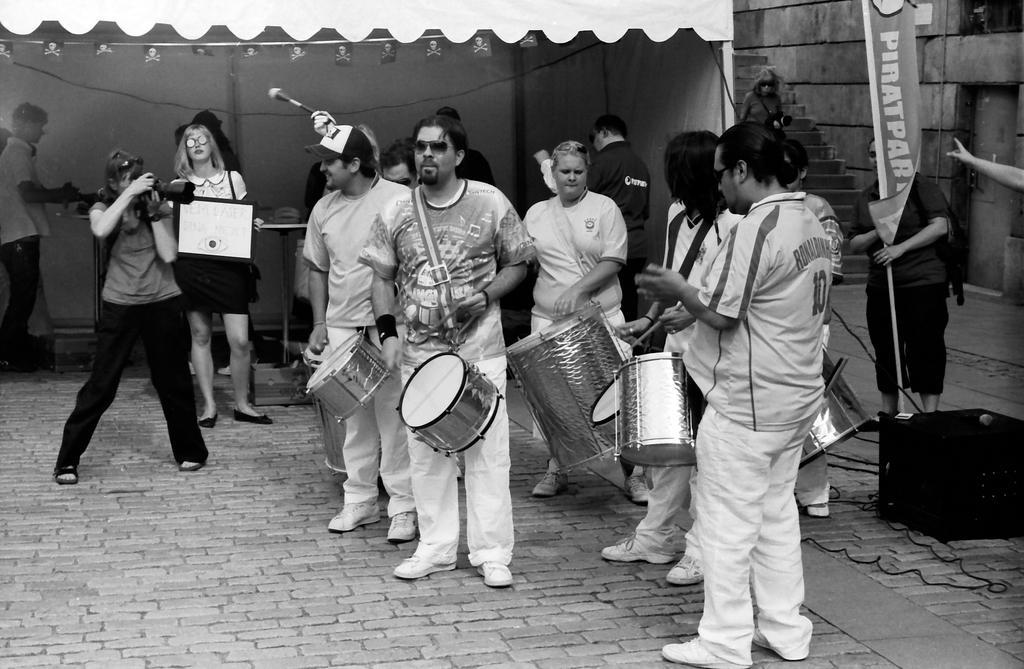How would you summarize this image in a sentence or two? There are many people playing drums. And one person wearing a white shirt and white pants is wearing a cap. In the front a person wearing goggles. And a lady wearing a black pants and t shirt is holding a camera. Behind her another lady is holding a photo frame. In the background there is a tent. And one person is holding mic. Also there is steps in the background. And there is a banner. 